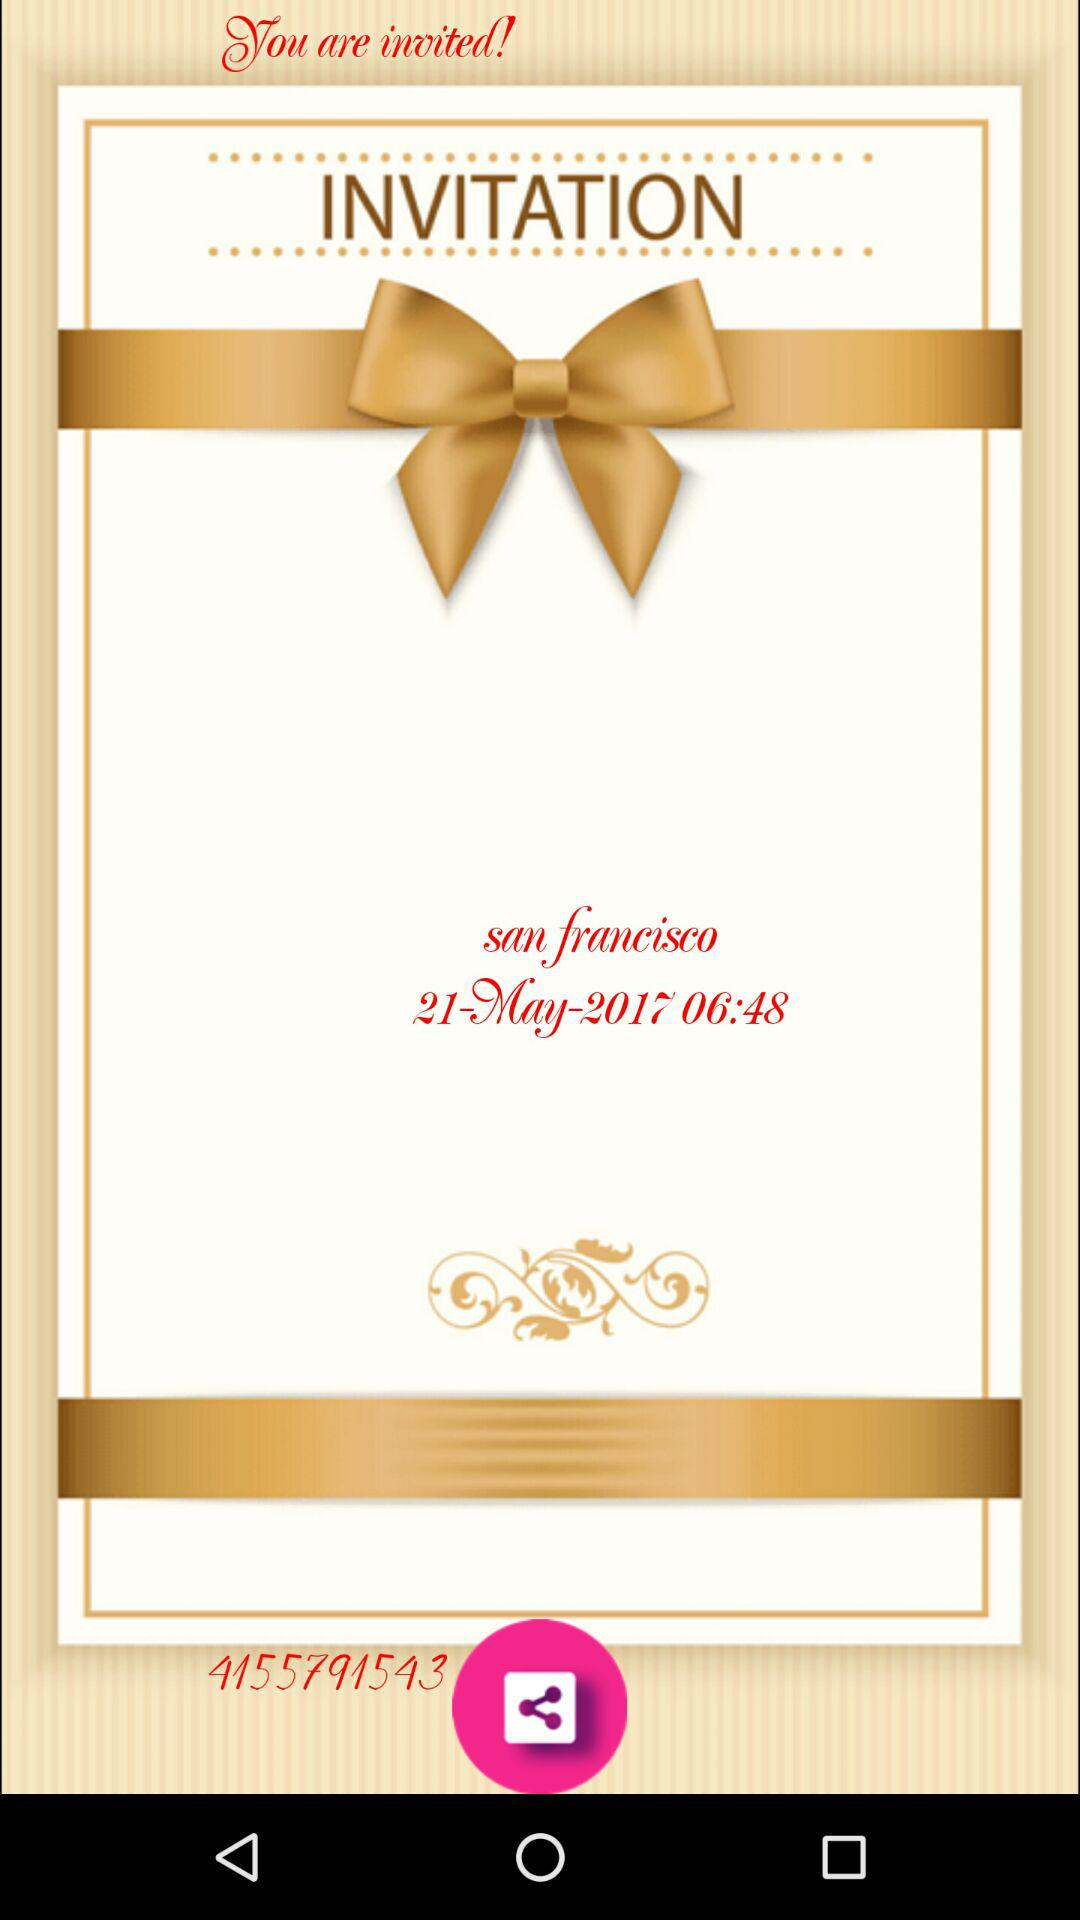What is the date of the invitation? The date of the invitation is May 21, 2017. 